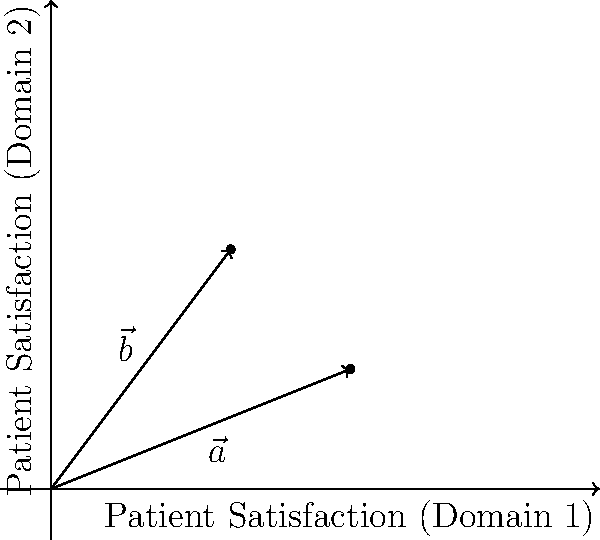In a healthcare system evaluation, two vectors $\vec{a} = (5, 2)$ and $\vec{b} = (3, 4)$ represent patient satisfaction scores in two different domains. Calculate the angle between these vectors to assess the overall alignment of patient satisfaction across these domains. To find the angle between two vectors, we can use the dot product formula:

$$\cos \theta = \frac{\vec{a} \cdot \vec{b}}{|\vec{a}||\vec{b}|}$$

Step 1: Calculate the dot product $\vec{a} \cdot \vec{b}$
$$\vec{a} \cdot \vec{b} = (5)(3) + (2)(4) = 15 + 8 = 23$$

Step 2: Calculate the magnitudes of $\vec{a}$ and $\vec{b}$
$$|\vec{a}| = \sqrt{5^2 + 2^2} = \sqrt{29}$$
$$|\vec{b}| = \sqrt{3^2 + 4^2} = \sqrt{25} = 5$$

Step 3: Substitute into the formula
$$\cos \theta = \frac{23}{\sqrt{29} \cdot 5}$$

Step 4: Solve for $\theta$
$$\theta = \arccos(\frac{23}{\sqrt{29} \cdot 5})$$

Step 5: Calculate the result (in degrees)
$$\theta \approx 22.6°$$
Answer: $22.6°$ 